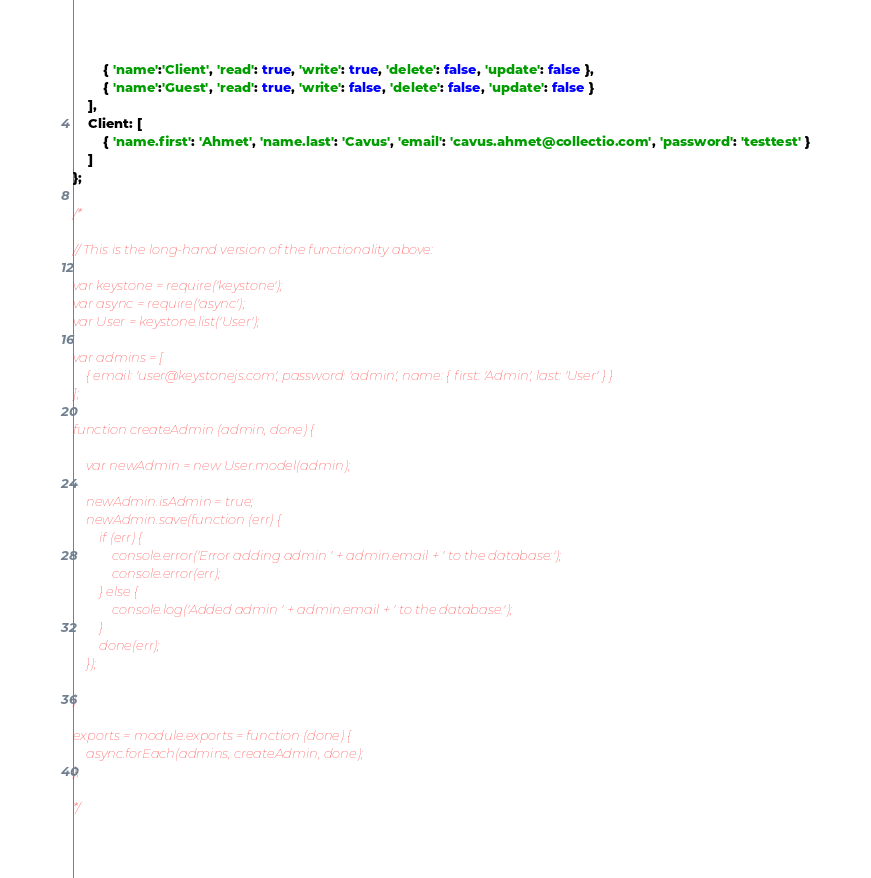Convert code to text. <code><loc_0><loc_0><loc_500><loc_500><_JavaScript_>		{ 'name':'Client', 'read': true, 'write': true, 'delete': false, 'update': false },
		{ 'name':'Guest', 'read': true, 'write': false, 'delete': false, 'update': false }
	],
    Client: [
        { 'name.first': 'Ahmet', 'name.last': 'Cavus', 'email': 'cavus.ahmet@collectio.com', 'password': 'testtest' }
	]
};

/*

// This is the long-hand version of the functionality above:

var keystone = require('keystone');
var async = require('async');
var User = keystone.list('User');

var admins = [
	{ email: 'user@keystonejs.com', password: 'admin', name: { first: 'Admin', last: 'User' } }
];

function createAdmin (admin, done) {

	var newAdmin = new User.model(admin);

	newAdmin.isAdmin = true;
	newAdmin.save(function (err) {
		if (err) {
			console.error('Error adding admin ' + admin.email + ' to the database:');
			console.error(err);
		} else {
			console.log('Added admin ' + admin.email + ' to the database.');
		}
		done(err);
	});

}

exports = module.exports = function (done) {
	async.forEach(admins, createAdmin, done);
};

*/
</code> 